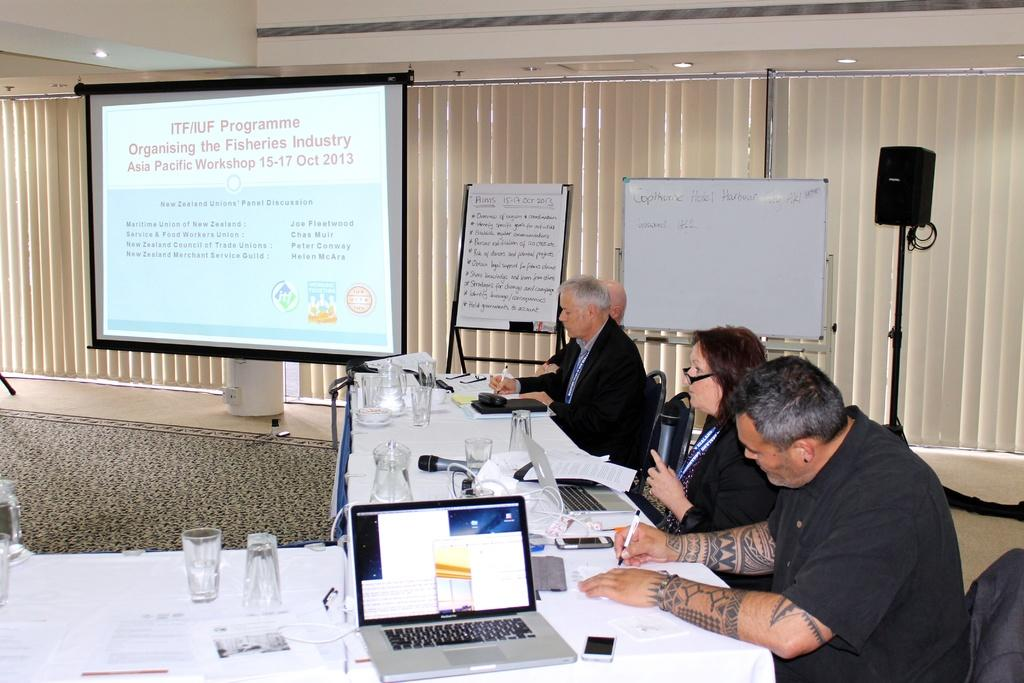<image>
Provide a brief description of the given image. A group is having a presentation around a number of table with a screen displaying the days Programme. 